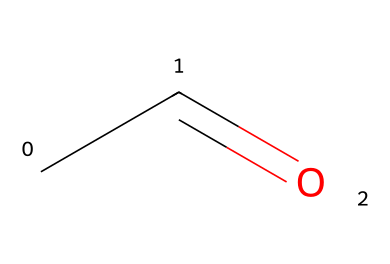What is the name of this chemical? The SMILES representation "CC=O" corresponds to Acetaldehyde, which is the common name for the compound. The structure indicates it has a carbonyl group and is thus classified as an aldehyde.
Answer: Acetaldehyde How many carbon atoms are present in this structure? In the SMILES "CC=O", there are two carbon atoms denoted by "CC". Each "C" represents a carbon atom, showing a total of two.
Answer: 2 What functional group characterizes this compound? The presence of the carbonyl group (C=O) adjacent to a carbon atom makes it an aldehyde. This specific arrangement defines the functional group of Acetaldehyde.
Answer: Aldehyde What is the total number of hydrogen atoms in Acetaldehyde? In the chemical structure represented by "CC=O", the two carbon atoms have three hydrogen atoms attached to one carbon and one hydrogen atom attached to the other. Therefore, there are a total of four hydrogen atoms in Acetaldehyde.
Answer: 4 How does Acetaldehyde typically form in fermentation processes? Acetaldehyde is produced as an intermediate during the fermentation of sugars by yeast, specifically during anaerobic respiration, where it is formed before being converted into ethanol.
Answer: Intermediate What is one potential use for Acetaldehyde in industrial applications? Acetaldehyde is commonly used as a precursor in the synthesis of various chemicals, including acetic acid, indicating its role in the chemical manufacturing sector.
Answer: Precursor 